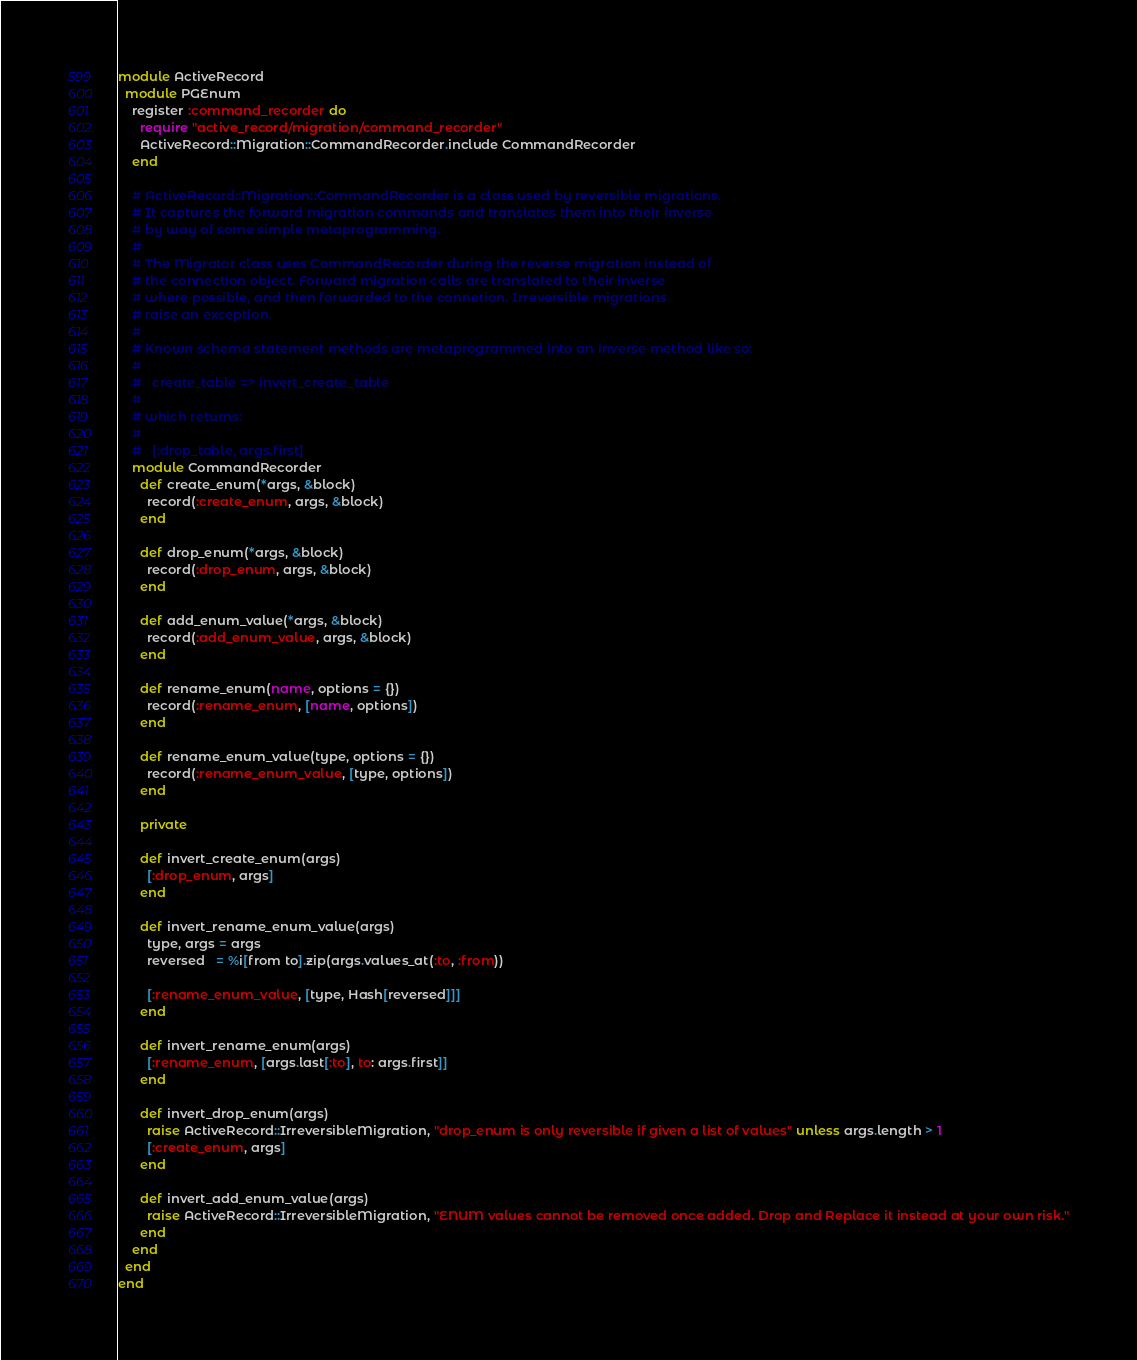Convert code to text. <code><loc_0><loc_0><loc_500><loc_500><_Ruby_>module ActiveRecord
  module PGEnum
    register :command_recorder do
      require "active_record/migration/command_recorder"
      ActiveRecord::Migration::CommandRecorder.include CommandRecorder
    end

    # ActiveRecord::Migration::CommandRecorder is a class used by reversible migrations.
    # It captures the forward migration commands and translates them into their inverse
    # by way of some simple metaprogramming.
    #
    # The Migrator class uses CommandRecorder during the reverse migration instead of
    # the connection object. Forward migration calls are translated to their inverse
    # where possible, and then forwarded to the connetion. Irreversible migrations
    # raise an exception.
    #
    # Known schema statement methods are metaprogrammed into an inverse method like so:
    #
    #   create_table => invert_create_table
    #
    # which returns:
    #
    #   [:drop_table, args.first]
    module CommandRecorder
      def create_enum(*args, &block)
        record(:create_enum, args, &block)
      end

      def drop_enum(*args, &block)
        record(:drop_enum, args, &block)
      end

      def add_enum_value(*args, &block)
        record(:add_enum_value, args, &block)
      end

      def rename_enum(name, options = {})
        record(:rename_enum, [name, options])
      end

      def rename_enum_value(type, options = {})
        record(:rename_enum_value, [type, options])
      end

      private

      def invert_create_enum(args)
        [:drop_enum, args]
      end

      def invert_rename_enum_value(args)
        type, args = args
        reversed   = %i[from to].zip(args.values_at(:to, :from))

        [:rename_enum_value, [type, Hash[reversed]]]
      end

      def invert_rename_enum(args)
        [:rename_enum, [args.last[:to], to: args.first]]
      end

      def invert_drop_enum(args)
        raise ActiveRecord::IrreversibleMigration, "drop_enum is only reversible if given a list of values" unless args.length > 1
        [:create_enum, args]
      end

      def invert_add_enum_value(args)
        raise ActiveRecord::IrreversibleMigration, "ENUM values cannot be removed once added. Drop and Replace it instead at your own risk."
      end
    end
  end
end
</code> 